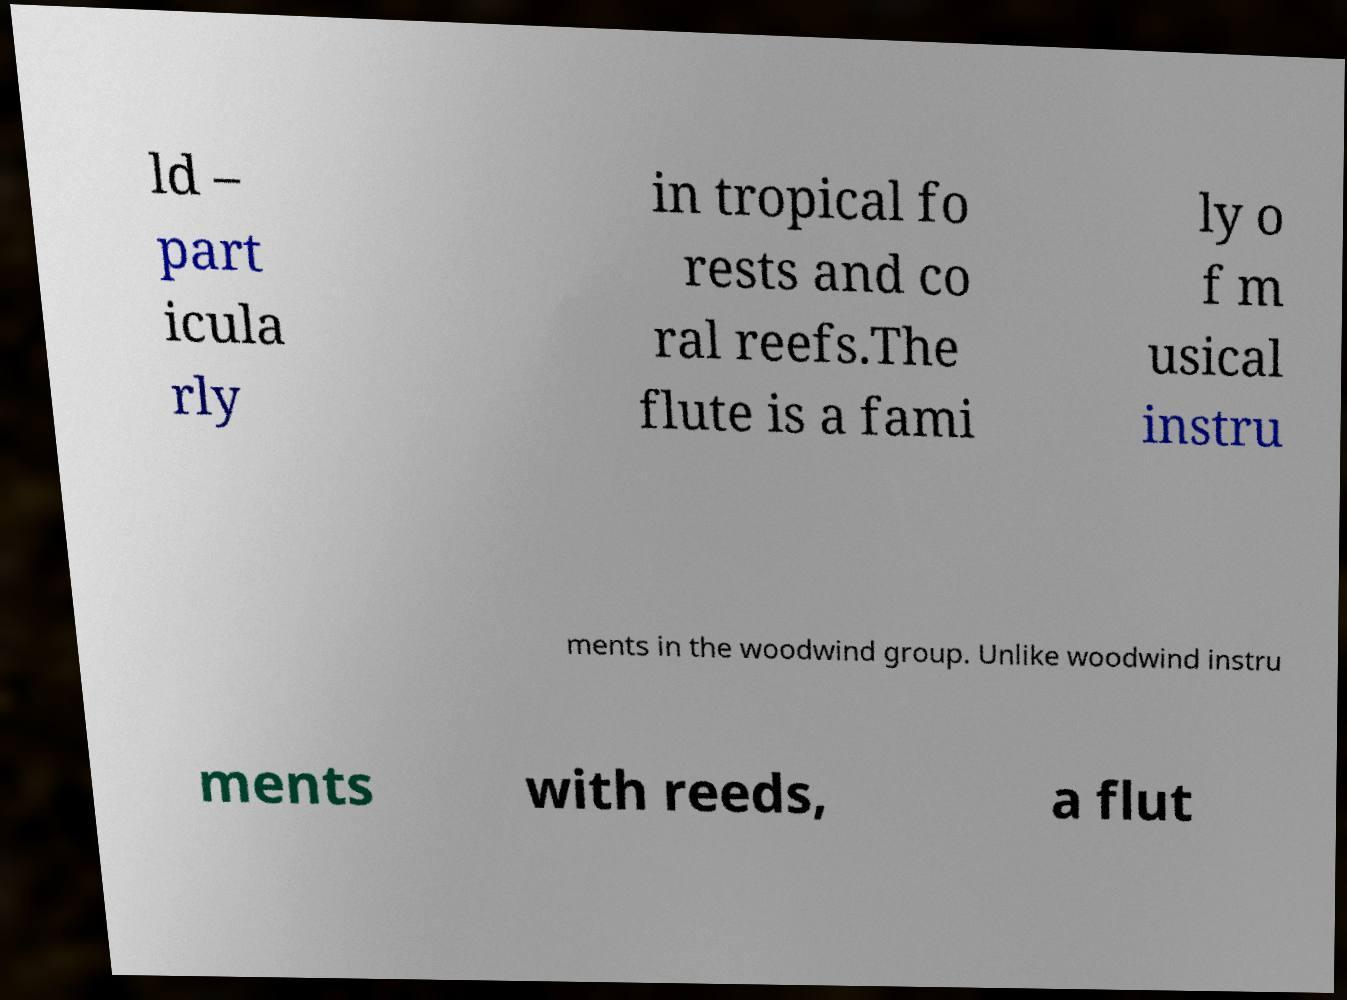Please read and relay the text visible in this image. What does it say? ld – part icula rly in tropical fo rests and co ral reefs.The flute is a fami ly o f m usical instru ments in the woodwind group. Unlike woodwind instru ments with reeds, a flut 